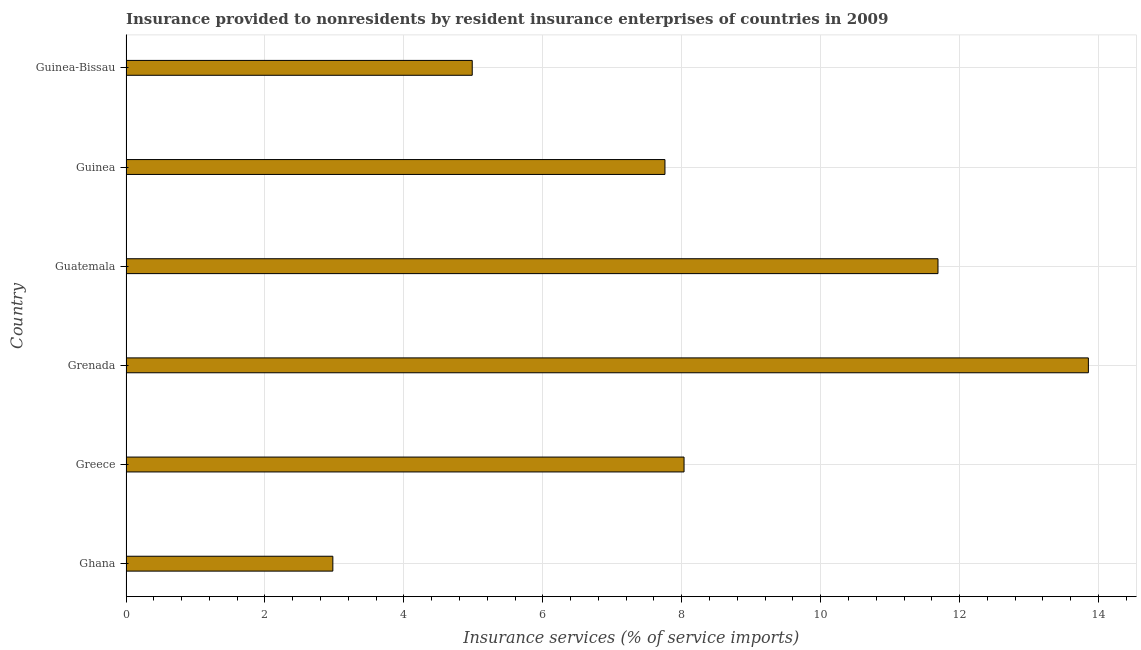What is the title of the graph?
Make the answer very short. Insurance provided to nonresidents by resident insurance enterprises of countries in 2009. What is the label or title of the X-axis?
Offer a terse response. Insurance services (% of service imports). What is the label or title of the Y-axis?
Give a very brief answer. Country. What is the insurance and financial services in Guinea?
Keep it short and to the point. 7.76. Across all countries, what is the maximum insurance and financial services?
Your response must be concise. 13.85. Across all countries, what is the minimum insurance and financial services?
Offer a very short reply. 2.98. In which country was the insurance and financial services maximum?
Your answer should be compact. Grenada. In which country was the insurance and financial services minimum?
Ensure brevity in your answer.  Ghana. What is the sum of the insurance and financial services?
Offer a terse response. 49.29. What is the difference between the insurance and financial services in Grenada and Guinea?
Offer a very short reply. 6.09. What is the average insurance and financial services per country?
Ensure brevity in your answer.  8.22. What is the median insurance and financial services?
Offer a terse response. 7.9. What is the ratio of the insurance and financial services in Ghana to that in Guatemala?
Give a very brief answer. 0.26. Is the difference between the insurance and financial services in Grenada and Guinea-Bissau greater than the difference between any two countries?
Your response must be concise. No. What is the difference between the highest and the second highest insurance and financial services?
Provide a succinct answer. 2.17. Is the sum of the insurance and financial services in Ghana and Guatemala greater than the maximum insurance and financial services across all countries?
Ensure brevity in your answer.  Yes. What is the difference between the highest and the lowest insurance and financial services?
Your answer should be very brief. 10.88. In how many countries, is the insurance and financial services greater than the average insurance and financial services taken over all countries?
Provide a short and direct response. 2. How many bars are there?
Give a very brief answer. 6. What is the difference between two consecutive major ticks on the X-axis?
Provide a succinct answer. 2. What is the Insurance services (% of service imports) of Ghana?
Your answer should be compact. 2.98. What is the Insurance services (% of service imports) in Greece?
Provide a succinct answer. 8.03. What is the Insurance services (% of service imports) in Grenada?
Make the answer very short. 13.85. What is the Insurance services (% of service imports) of Guatemala?
Keep it short and to the point. 11.69. What is the Insurance services (% of service imports) of Guinea?
Offer a terse response. 7.76. What is the Insurance services (% of service imports) in Guinea-Bissau?
Offer a very short reply. 4.98. What is the difference between the Insurance services (% of service imports) in Ghana and Greece?
Give a very brief answer. -5.06. What is the difference between the Insurance services (% of service imports) in Ghana and Grenada?
Give a very brief answer. -10.88. What is the difference between the Insurance services (% of service imports) in Ghana and Guatemala?
Provide a succinct answer. -8.71. What is the difference between the Insurance services (% of service imports) in Ghana and Guinea?
Offer a terse response. -4.78. What is the difference between the Insurance services (% of service imports) in Ghana and Guinea-Bissau?
Provide a succinct answer. -2.01. What is the difference between the Insurance services (% of service imports) in Greece and Grenada?
Give a very brief answer. -5.82. What is the difference between the Insurance services (% of service imports) in Greece and Guatemala?
Provide a short and direct response. -3.66. What is the difference between the Insurance services (% of service imports) in Greece and Guinea?
Give a very brief answer. 0.27. What is the difference between the Insurance services (% of service imports) in Greece and Guinea-Bissau?
Offer a very short reply. 3.05. What is the difference between the Insurance services (% of service imports) in Grenada and Guatemala?
Offer a terse response. 2.16. What is the difference between the Insurance services (% of service imports) in Grenada and Guinea?
Make the answer very short. 6.1. What is the difference between the Insurance services (% of service imports) in Grenada and Guinea-Bissau?
Provide a short and direct response. 8.87. What is the difference between the Insurance services (% of service imports) in Guatemala and Guinea?
Keep it short and to the point. 3.93. What is the difference between the Insurance services (% of service imports) in Guatemala and Guinea-Bissau?
Ensure brevity in your answer.  6.7. What is the difference between the Insurance services (% of service imports) in Guinea and Guinea-Bissau?
Give a very brief answer. 2.77. What is the ratio of the Insurance services (% of service imports) in Ghana to that in Greece?
Keep it short and to the point. 0.37. What is the ratio of the Insurance services (% of service imports) in Ghana to that in Grenada?
Provide a succinct answer. 0.21. What is the ratio of the Insurance services (% of service imports) in Ghana to that in Guatemala?
Make the answer very short. 0.26. What is the ratio of the Insurance services (% of service imports) in Ghana to that in Guinea?
Your response must be concise. 0.38. What is the ratio of the Insurance services (% of service imports) in Ghana to that in Guinea-Bissau?
Provide a succinct answer. 0.6. What is the ratio of the Insurance services (% of service imports) in Greece to that in Grenada?
Make the answer very short. 0.58. What is the ratio of the Insurance services (% of service imports) in Greece to that in Guatemala?
Ensure brevity in your answer.  0.69. What is the ratio of the Insurance services (% of service imports) in Greece to that in Guinea?
Offer a terse response. 1.03. What is the ratio of the Insurance services (% of service imports) in Greece to that in Guinea-Bissau?
Give a very brief answer. 1.61. What is the ratio of the Insurance services (% of service imports) in Grenada to that in Guatemala?
Make the answer very short. 1.19. What is the ratio of the Insurance services (% of service imports) in Grenada to that in Guinea?
Your answer should be compact. 1.79. What is the ratio of the Insurance services (% of service imports) in Grenada to that in Guinea-Bissau?
Offer a very short reply. 2.78. What is the ratio of the Insurance services (% of service imports) in Guatemala to that in Guinea?
Make the answer very short. 1.51. What is the ratio of the Insurance services (% of service imports) in Guatemala to that in Guinea-Bissau?
Offer a very short reply. 2.35. What is the ratio of the Insurance services (% of service imports) in Guinea to that in Guinea-Bissau?
Offer a very short reply. 1.56. 